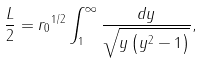<formula> <loc_0><loc_0><loc_500><loc_500>\frac { L } { 2 } = { r _ { 0 } } ^ { 1 / 2 } \int _ { 1 } ^ { \infty } \frac { d y } { \sqrt { y \left ( y ^ { 2 } - 1 \right ) } } ,</formula> 